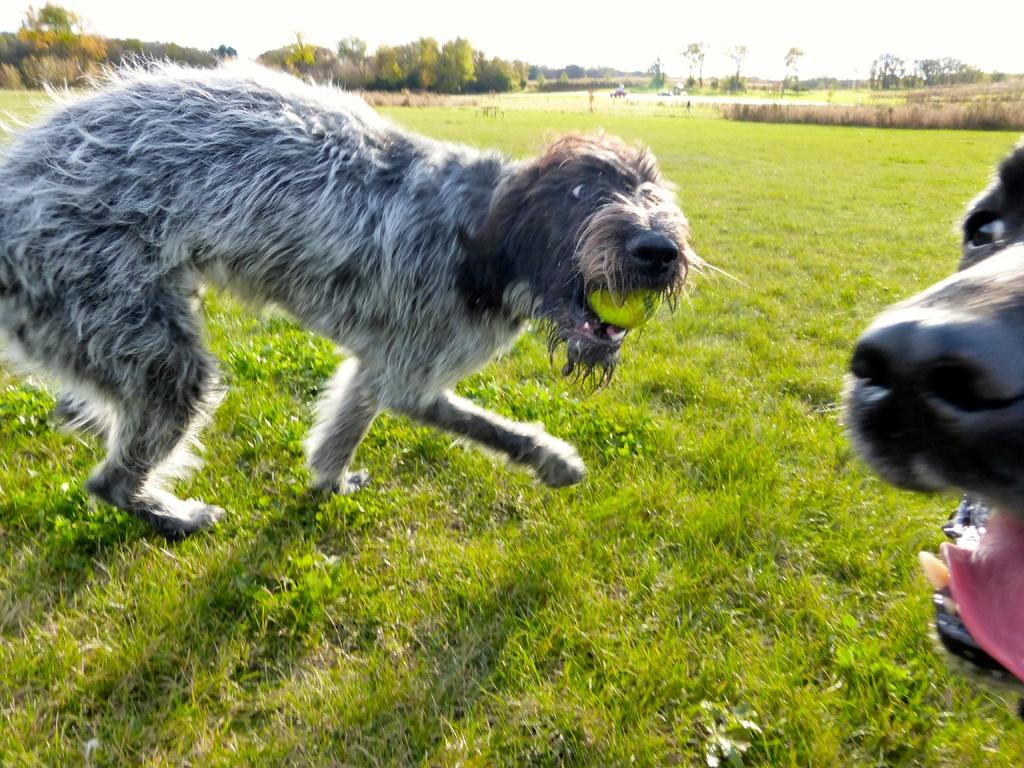How many dogs are present in the image? There are two dogs in the image. Where are the dogs located? The dogs are on a grassy land. What can be seen in the background of the image? There are trees in the background of the image. What type of frame is surrounding the dogs in the image? There is no frame surrounding the dogs in the image; they are on a grassy land. Is there any indication of death or dying in the image? No, there is no indication of death or dying in the image. 